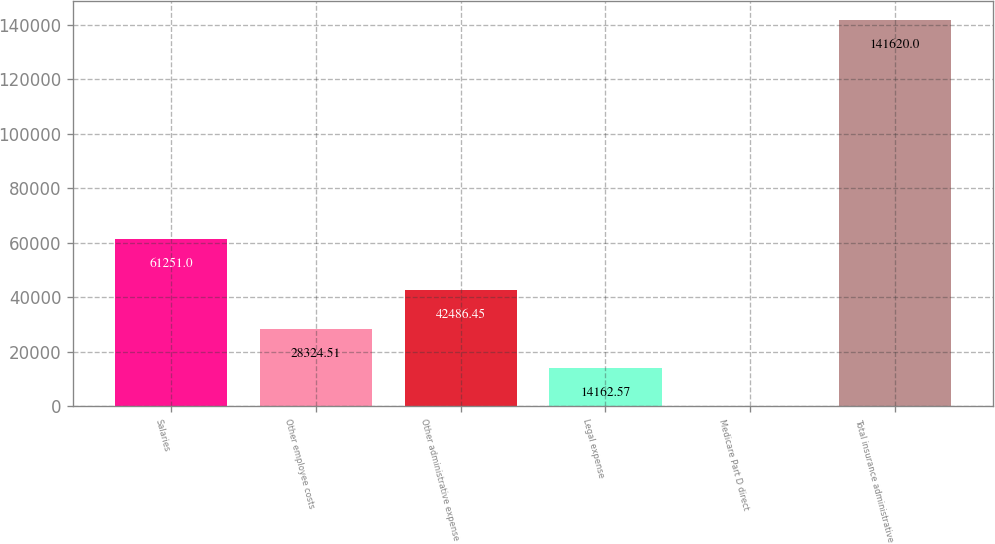Convert chart to OTSL. <chart><loc_0><loc_0><loc_500><loc_500><bar_chart><fcel>Salaries<fcel>Other employee costs<fcel>Other administrative expense<fcel>Legal expense<fcel>Medicare Part D direct<fcel>Total insurance administrative<nl><fcel>61251<fcel>28324.5<fcel>42486.4<fcel>14162.6<fcel>0.63<fcel>141620<nl></chart> 